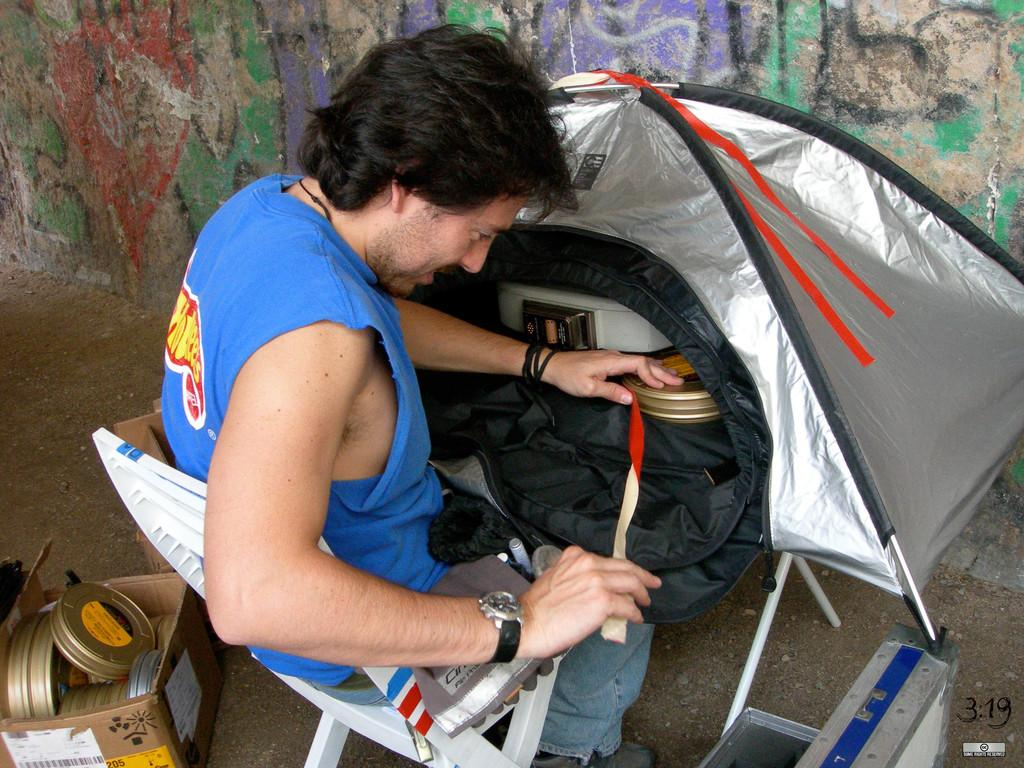What is the person in the image doing? The person is sitting on a chair in the image. What color is the person's shirt? The person is wearing a blue shirt. What color are the person's pants? The person is wearing blue pants. What is the person holding in the image? The person is holding an object. What can be seen in the background of the image? There is a wall in the background of the image. How many colors are on the wall in the image? The wall has multiple colors. What type of creature is sitting on the person's lap in the image? There is no creature present in the image; the person is sitting alone on the chair. What kind of doll is sitting next to the person on the chair? There is no doll present in the image; the person is sitting alone on the chair. 